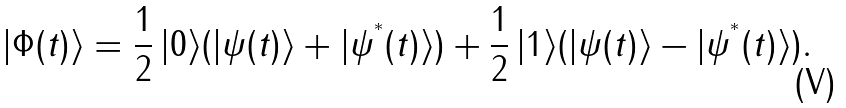<formula> <loc_0><loc_0><loc_500><loc_500>| \Phi ( t ) \rangle = \frac { 1 } { 2 } \, | 0 \rangle ( | \psi ( t ) \rangle + | \psi ^ { ^ { * } } ( t ) \rangle ) + \frac { 1 } { 2 } \, | 1 \rangle ( | \psi ( t ) \rangle - | \psi ^ { ^ { * } } ( t ) \rangle ) .</formula> 